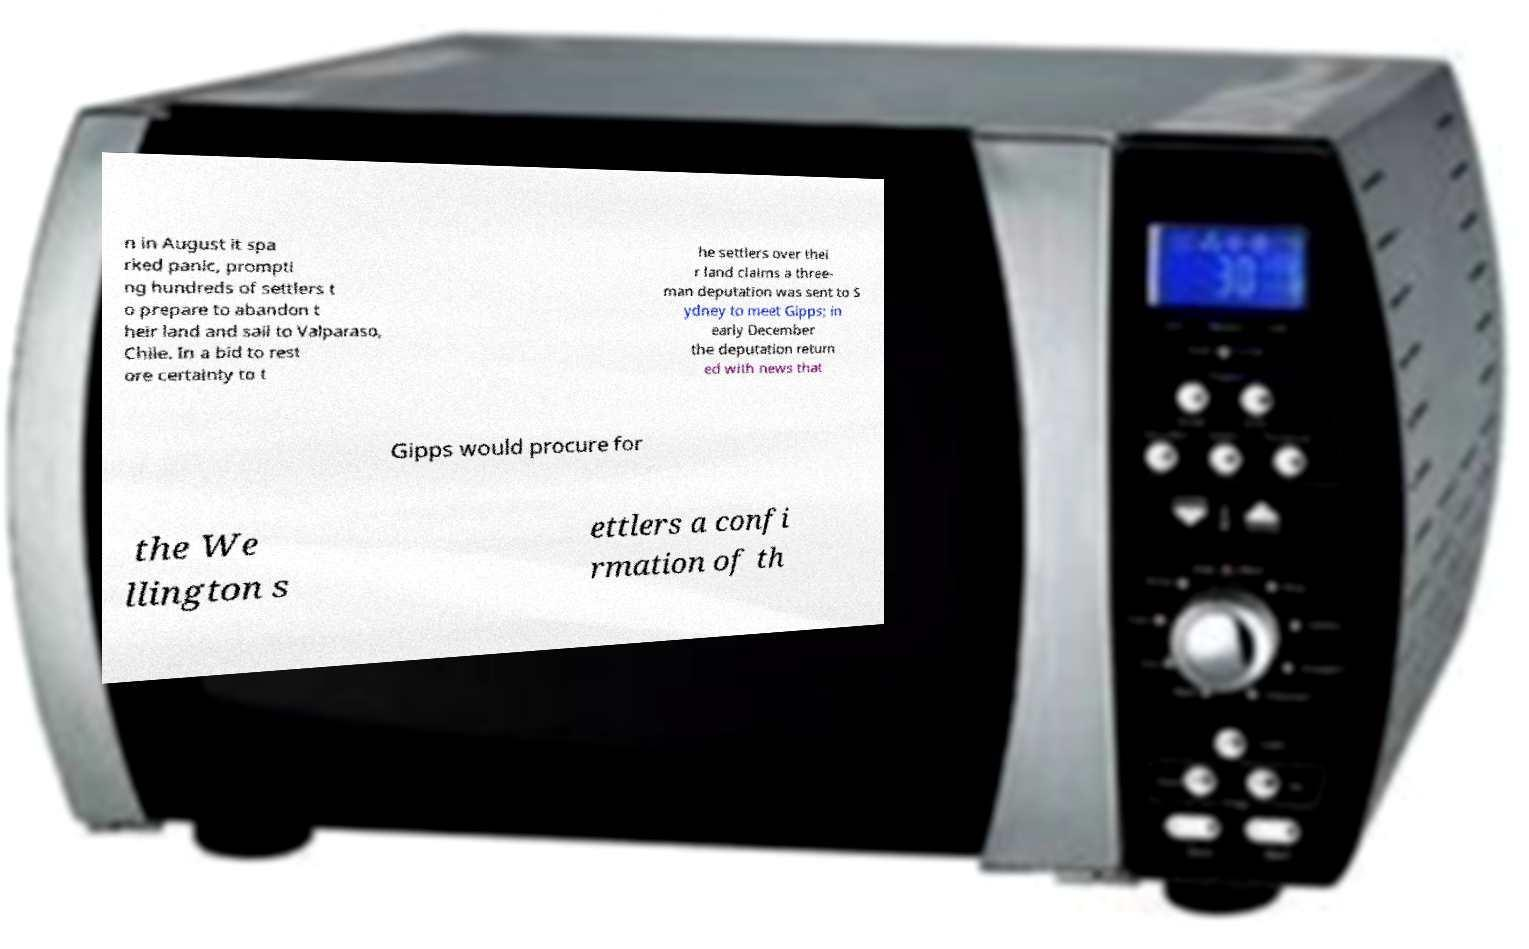What messages or text are displayed in this image? I need them in a readable, typed format. n in August it spa rked panic, prompti ng hundreds of settlers t o prepare to abandon t heir land and sail to Valparaso, Chile. In a bid to rest ore certainty to t he settlers over thei r land claims a three- man deputation was sent to S ydney to meet Gipps; in early December the deputation return ed with news that Gipps would procure for the We llington s ettlers a confi rmation of th 